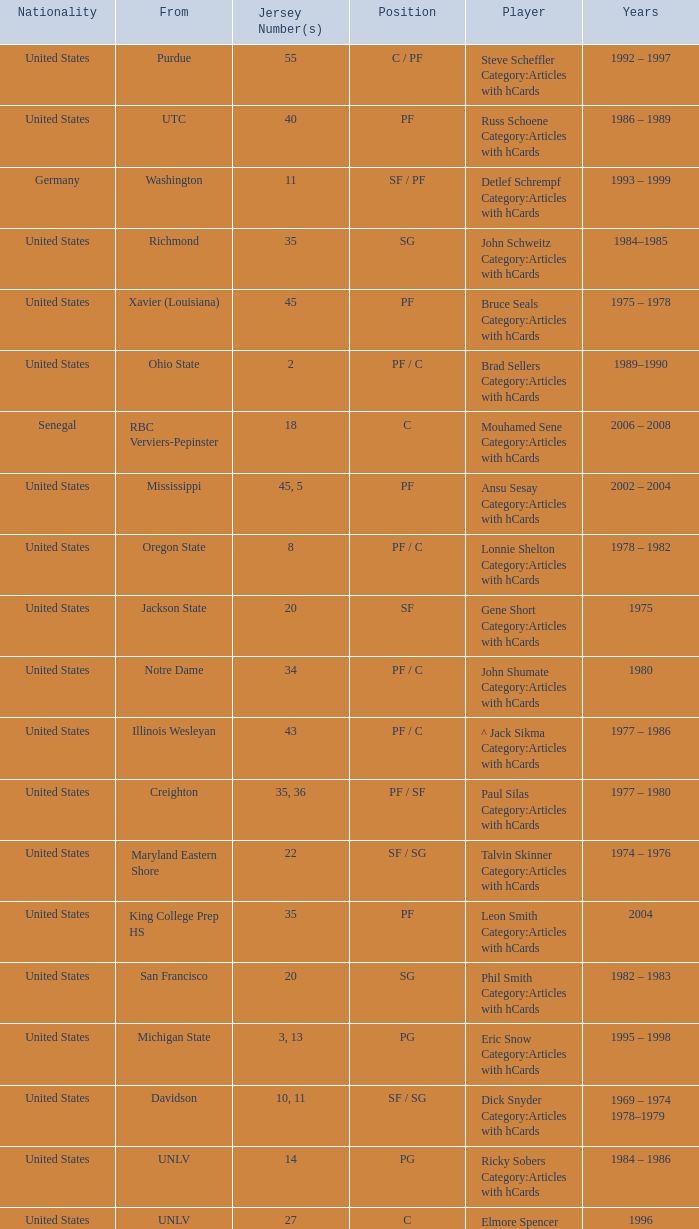What position does the player with jersey number 22 play? SF / SG. 